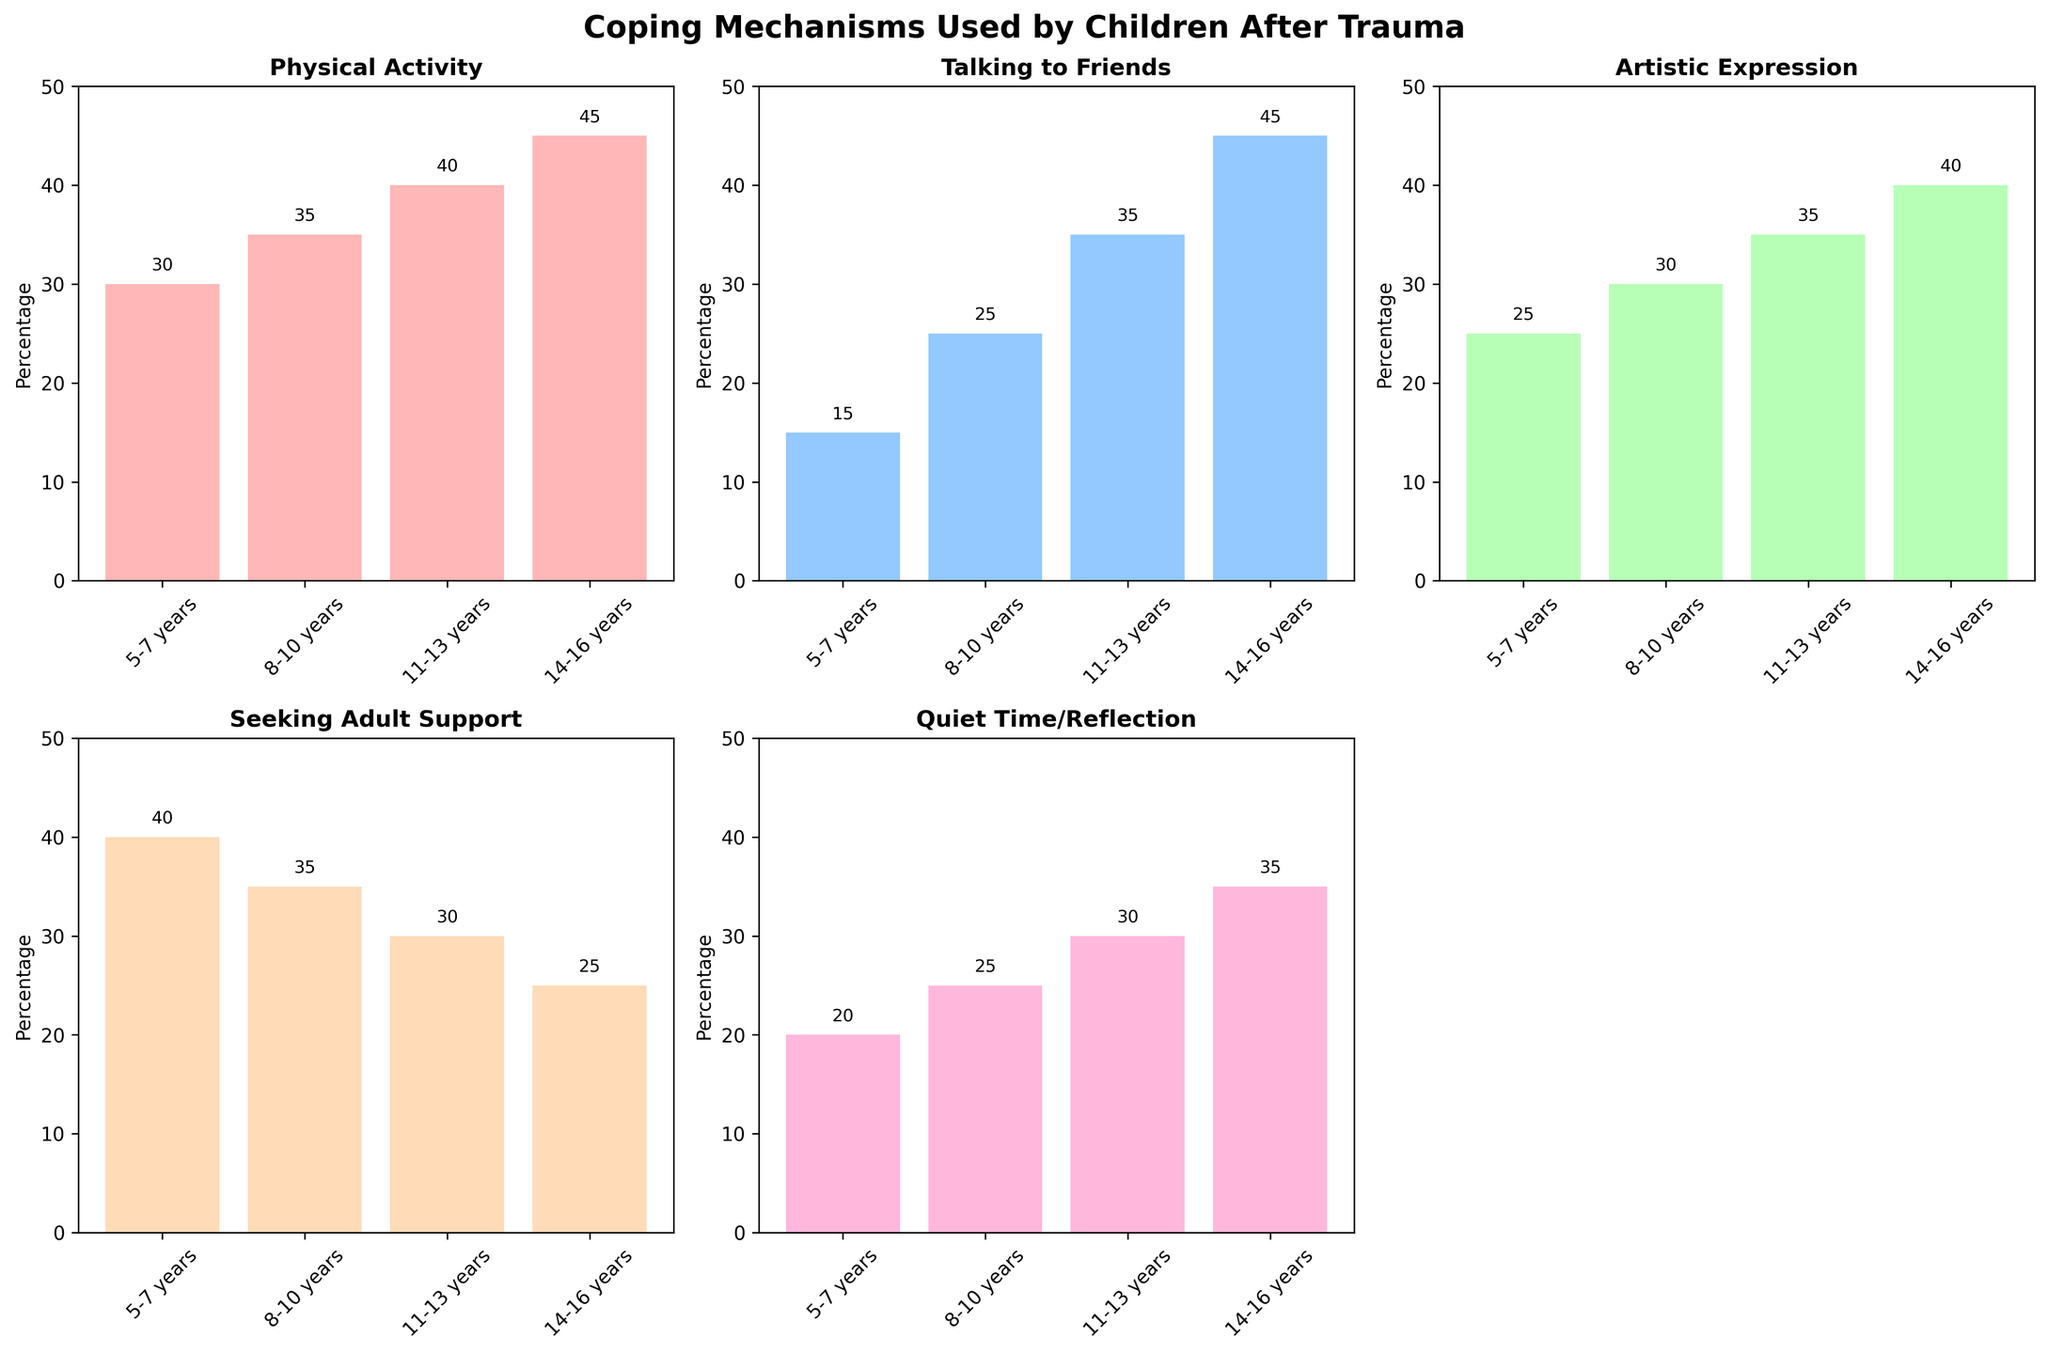What coping mechanism is used most by children aged 5-7 years? Look at the bar height for the 5-7 years age group across all subplots. The tallest bar represents the most used coping mechanism.
Answer: Seeking Adult Support Which age group uses Quiet Time/Reflection the least? Look at the subplot for Quiet Time/Reflection and compare the bar heights for different age groups. The shortest bar indicates the least use.
Answer: 5-7 years What's the sum of percentages for Talking to Friends used by children aged 11-13 years and 14-16 years? Find the bars for Talking to Friends for the 11-13 years and 14-16 years groups and sum their heights.
Answer: 80 Is there an age group that has the highest percentage for both Artistic Expression and Physical Activity? Check if there is an age group that has the tallest bars in both Artistic Expression and Physical Activity subplots.
Answer: No Which coping mechanism shows a steady increase in usage with age? Analyze each subplot to see if the bars increase consistently from 5-7 years to 14-16 years.
Answer: Physical Activity What is the percentage difference in Seeking Adult Support between children aged 8-10 years and 14-16 years? Find the bar heights for Seeking Adult Support for both age groups and subtract the smaller value from the larger one.
Answer: 10 Which coping mechanism has the smallest variance across different age groups? Look at the subplots and visually estimate which mechanism has bars of similar height for all age groups.
Answer: Quiet Time/Reflection In the Artistic Expression subplot, what is the combined percentage of the youngest and oldest age groups? Add the heights of the bars for 5-7 years and 14-16 years in the Artistic Expression subplot.
Answer: 65 Which age group has the most balanced distribution across all coping mechanisms? Look at each age group across all subplots and find the group where the bars are most similar in height.
Answer: 8-10 years For age group 8-10 years, which coping mechanism is used least? Look at the 8-10 years age group across all subplots and find the shortest bar.
Answer: Seeking Adult Support 